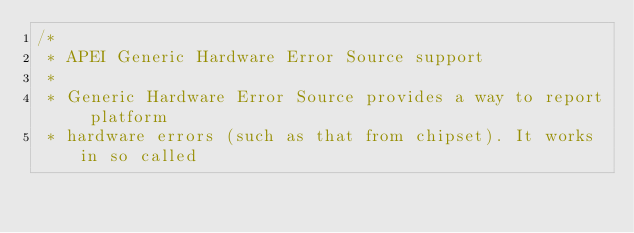<code> <loc_0><loc_0><loc_500><loc_500><_C_>/*
 * APEI Generic Hardware Error Source support
 *
 * Generic Hardware Error Source provides a way to report platform
 * hardware errors (such as that from chipset). It works in so called</code> 